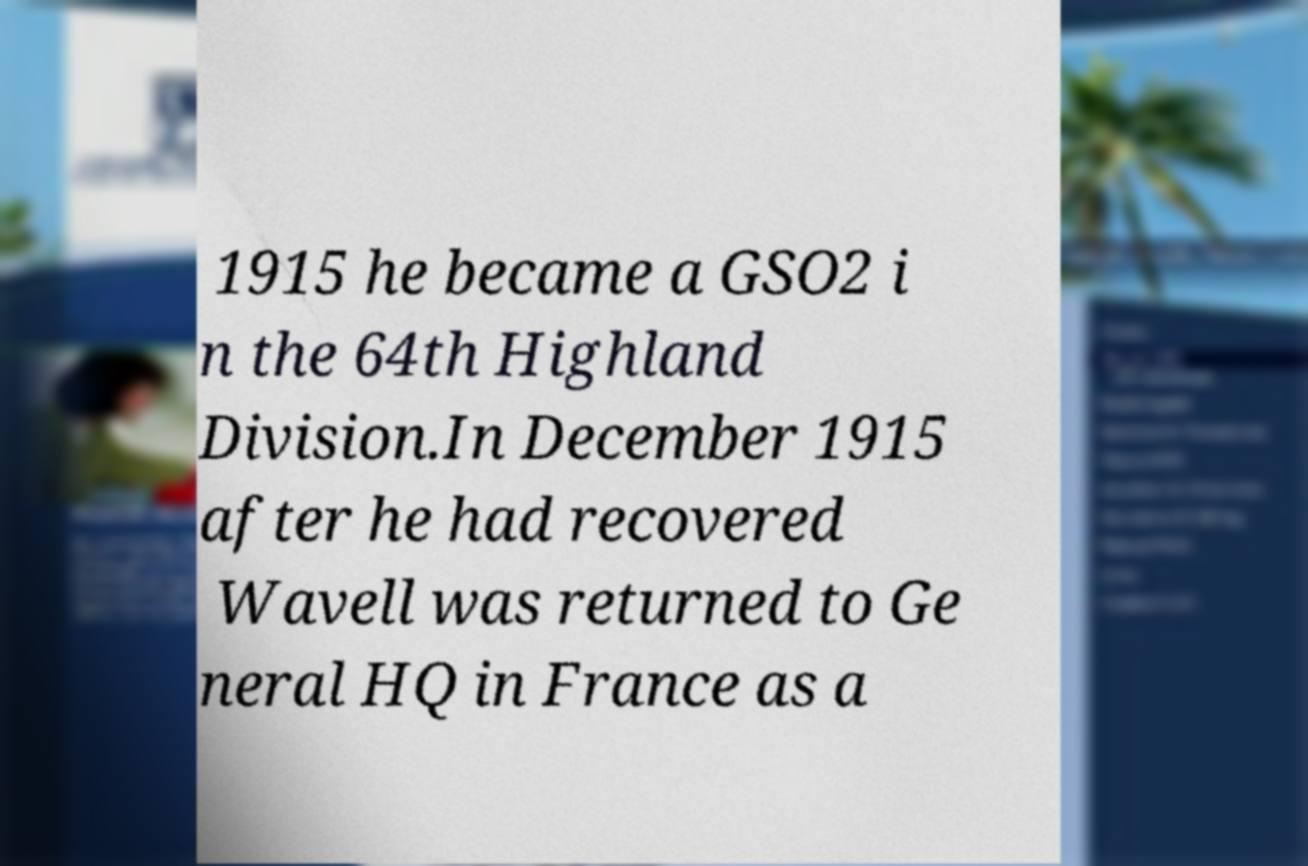Could you assist in decoding the text presented in this image and type it out clearly? 1915 he became a GSO2 i n the 64th Highland Division.In December 1915 after he had recovered Wavell was returned to Ge neral HQ in France as a 